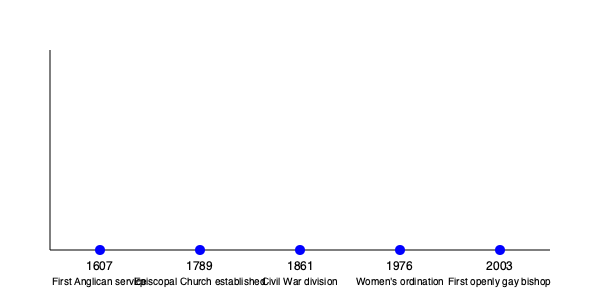Based on the timeline of significant events in the Episcopal Church's history, how many years passed between the establishment of the Episcopal Church and the ordination of women? To find the answer, we need to follow these steps:

1. Identify the year when the Episcopal Church was established:
   The timeline shows this occurred in 1789.

2. Identify the year when women's ordination was approved:
   The timeline indicates this happened in 1976.

3. Calculate the difference between these two years:
   $1976 - 1789 = 187$

Therefore, 187 years passed between the establishment of the Episcopal Church and the ordination of women.
Answer: 187 years 